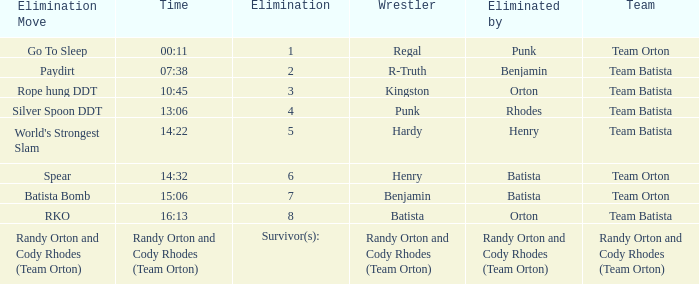Which Wrestler plays for Team Batista which was Elimated by Orton on Elimination 8? Batista. 